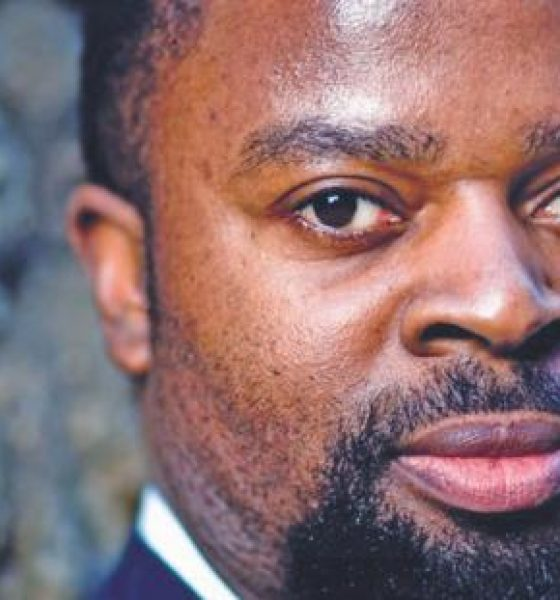What kind of personality traits can be inferred from the subject's expression and appearance in this photograph? The subject's expression in this photograph appears focused and composed, suggesting traits such as confidence, determination, and professionalism. The direct gaze and the firm line of the lips indicate a serious and resolute demeanor. Overall, the image projects an aura of reliability and competence. 